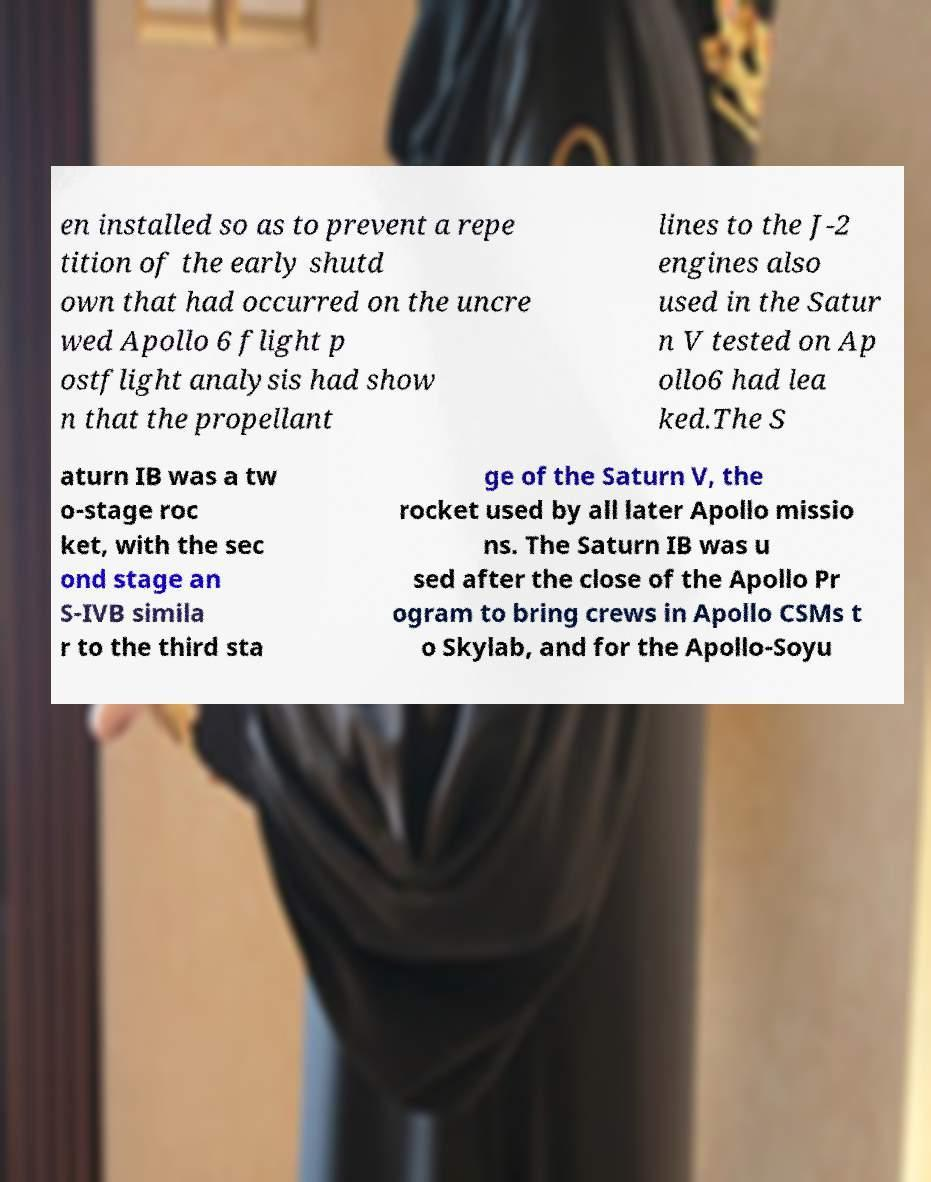Can you accurately transcribe the text from the provided image for me? en installed so as to prevent a repe tition of the early shutd own that had occurred on the uncre wed Apollo 6 flight p ostflight analysis had show n that the propellant lines to the J-2 engines also used in the Satur n V tested on Ap ollo6 had lea ked.The S aturn IB was a tw o-stage roc ket, with the sec ond stage an S-IVB simila r to the third sta ge of the Saturn V, the rocket used by all later Apollo missio ns. The Saturn IB was u sed after the close of the Apollo Pr ogram to bring crews in Apollo CSMs t o Skylab, and for the Apollo-Soyu 